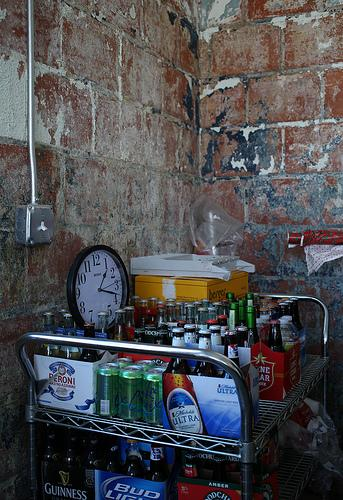Estimate the time shown on the clock and list any visible features of the clock. The time is approximately 1:18, and the clock is a circle-shaped with a black frame, black numbers, and black hands, placed near the brick wall. Describe the type of cart containing the beer, and identify any notable features on the cart. The cart is a silver metal cart with a silver handle, containing various cans and bottles of beer, and it measures approximately 322 pixels in width and height. List three types of beer visible in the image and describe their packaging color and/or text. 3. Guinness beer in a twelve-pack carton Identify the type and color of cans with blue writing and provide their approximate size. The cans are green La Croix cans with blue writing, and each can measures approximately 85 pixels in width and height. Identify the central object in the image and describe its characteristics. The central object is a round clock with a black frame, black numbers, and black hands, with the small hand pointing at 1 and the larger hand pointing downward. Comment on the quality of the brick wall, and identify any features present on the wall. The brick wall has a worn and dirty appearance, with chipping paint and many marks. There's also a light switch and a socket on the wall. Count the number of beer brands visible in the image and describe the packaging of at least two brands. There are five different beer brands visible. One is a case of Michelob beer in a yellow cardboard box, and another is a twelve-pack of Bud Light in a blue carton with "Bud" written on the side. Explain the sentiment of the image and provide a reason for your assessment. The sentiment of the image is neutral, as it depicts a normal scene of a brick wall with a clock and various beer brands on a cart, without any strong emotions or feelings conveyed. Provide a brief description of the scene depicted in the image. The image shows a brick wall with a clock, various beer brands on a metal cart, a light switch, and some miscellaneous items like an umbrella and a plastic cover. What is the color, shape, and size of the umbrella in the image? The umbrella is red and green, with a slightly rolled, elongated shape and measures approximately 63 pixels in width and height. Identify the color of the cart holding cans and bottles. silver metal cart Find the cute kitten sitting in front of the beer cases and observe its colors. No, it's not mentioned in the image. Describe the appearance and condition of the brick wall. red brick wall with many marks and chipping paint What activity or event is taking place in this image? There is no specific activity or event, just objects. Which color describes the clock's frame? black What word can you see on a carton in the image? Bud Which of the following is not found on the clock: numbers, small hand, larger hand, or black hands? black hands What is the main object in front of the wall? clock Please point out the vintage telephone hanging on the brick wall right above the socket. There is no mention of a telephone or its placement on the wall in the list of objects, so this object does not exist in the image. Examine the bricks and describe their state. dirty bricks on the walls Can you spot any painting or artwork in the image? No, there are no paintings or artwork. What are the contents of the yellow box? Six cans of La Croix Mention the expression of a person in the image. There are no people in the image. Can you tell me the color of the balloons tied to the metal cart? There is no mention of balloons or their attachment to the metal cart in the list of objects, so this object does not exist in the image. Describe the umbrella found in the image. red and green umbrella What is being displayed on the silver cart? beer on a metal cart List the types of beer present in the picture. Guinness, Michelob, Bud Light, and La Croix Where is a socket located in the picture? in the wall What does the umbrella in the image look like? red and green umbrella on the side State the condition of the clock's frame. a clock with a black frame Explain what seems to be the state of the light switch. silver light switch on the wall Identify the object with a black frame near the wall. a clock 